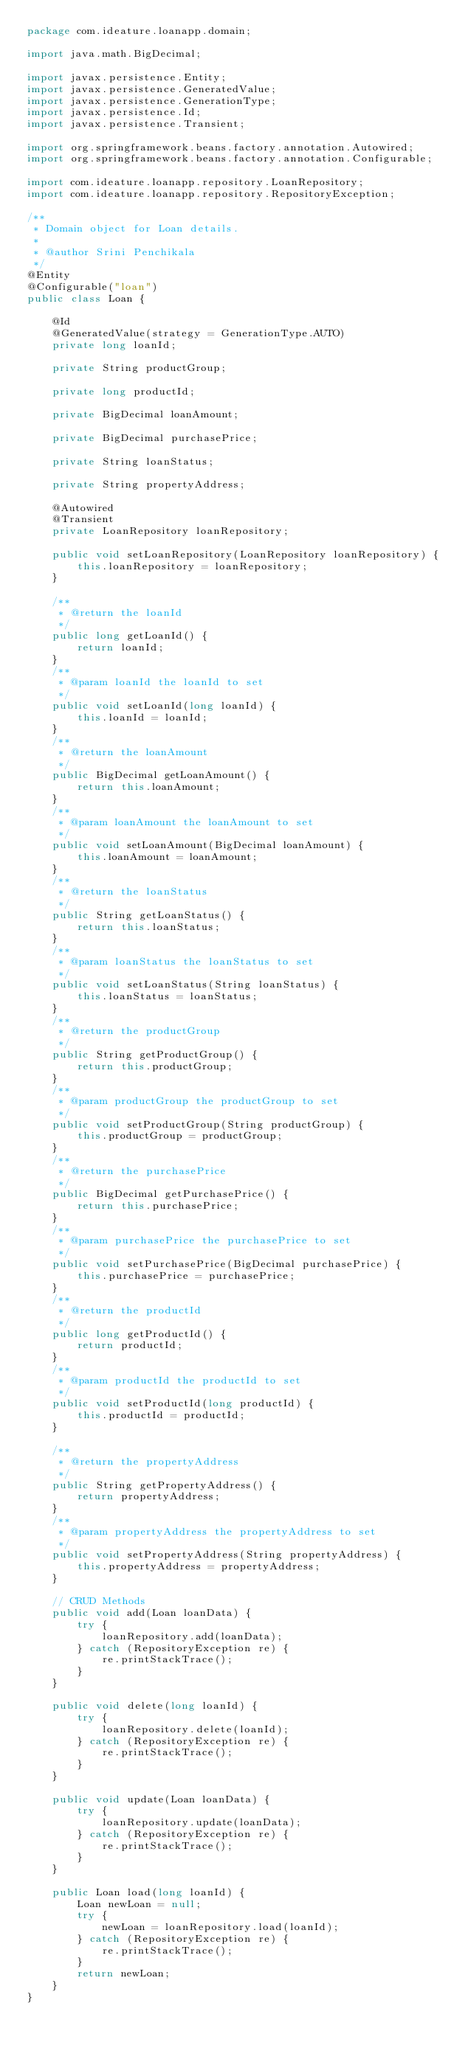Convert code to text. <code><loc_0><loc_0><loc_500><loc_500><_Java_>package com.ideature.loanapp.domain;

import java.math.BigDecimal;

import javax.persistence.Entity;
import javax.persistence.GeneratedValue;
import javax.persistence.GenerationType;
import javax.persistence.Id;
import javax.persistence.Transient;

import org.springframework.beans.factory.annotation.Autowired;
import org.springframework.beans.factory.annotation.Configurable;

import com.ideature.loanapp.repository.LoanRepository;
import com.ideature.loanapp.repository.RepositoryException;

/**
 * Domain object for Loan details.
 *
 * @author Srini Penchikala
 */
@Entity
@Configurable("loan")
public class Loan {

	@Id
	@GeneratedValue(strategy = GenerationType.AUTO)
	private long loanId;

	private String productGroup;

	private long productId;

	private BigDecimal loanAmount;

	private BigDecimal purchasePrice;

	private String loanStatus;

	private String propertyAddress;
	
	@Autowired
	@Transient
	private LoanRepository loanRepository;
	
	public void setLoanRepository(LoanRepository loanRepository) {
		this.loanRepository = loanRepository;
	}

	/**
	 * @return the loanId
	 */
	public long getLoanId() {
		return loanId;
	}
	/**
	 * @param loanId the loanId to set
	 */
	public void setLoanId(long loanId) {
		this.loanId = loanId;
	}
	/**
	 * @return the loanAmount
	 */
	public BigDecimal getLoanAmount() {
		return this.loanAmount;
	}
	/**
	 * @param loanAmount the loanAmount to set
	 */
	public void setLoanAmount(BigDecimal loanAmount) {
		this.loanAmount = loanAmount;
	}
	/**
	 * @return the loanStatus
	 */
	public String getLoanStatus() {
		return this.loanStatus;
	}
	/**
	 * @param loanStatus the loanStatus to set
	 */
	public void setLoanStatus(String loanStatus) {
		this.loanStatus = loanStatus;
	}
	/**
	 * @return the productGroup
	 */
	public String getProductGroup() {
		return this.productGroup;
	}
	/**
	 * @param productGroup the productGroup to set
	 */
	public void setProductGroup(String productGroup) {
		this.productGroup = productGroup;
	}
	/**
	 * @return the purchasePrice
	 */
	public BigDecimal getPurchasePrice() {
		return this.purchasePrice;
	}
	/**
	 * @param purchasePrice the purchasePrice to set
	 */
	public void setPurchasePrice(BigDecimal purchasePrice) {
		this.purchasePrice = purchasePrice;
	}
	/**
	 * @return the productId
	 */
	public long getProductId() {
		return productId;
	}
	/**
	 * @param productId the productId to set
	 */
	public void setProductId(long productId) {
		this.productId = productId;
	}

	/**
	 * @return the propertyAddress
	 */
	public String getPropertyAddress() {
		return propertyAddress;
	}
	/**
	 * @param propertyAddress the propertyAddress to set
	 */
	public void setPropertyAddress(String propertyAddress) {
		this.propertyAddress = propertyAddress;
	}
	
	// CRUD Methods
	public void add(Loan loanData) {
		try {
			loanRepository.add(loanData);
		} catch (RepositoryException re) {
			re.printStackTrace();
		}
	}

	public void delete(long loanId) {
		try {
			loanRepository.delete(loanId);
		} catch (RepositoryException re) {
			re.printStackTrace();
		}
	}
	
	public void update(Loan loanData) {
		try {
			loanRepository.update(loanData);
		} catch (RepositoryException re) {
			re.printStackTrace();
		}
	}

	public Loan load(long loanId) {
		Loan newLoan = null;
		try {
			newLoan = loanRepository.load(loanId);
		} catch (RepositoryException re) {
			re.printStackTrace();
		}
		return newLoan;
	}
}
</code> 